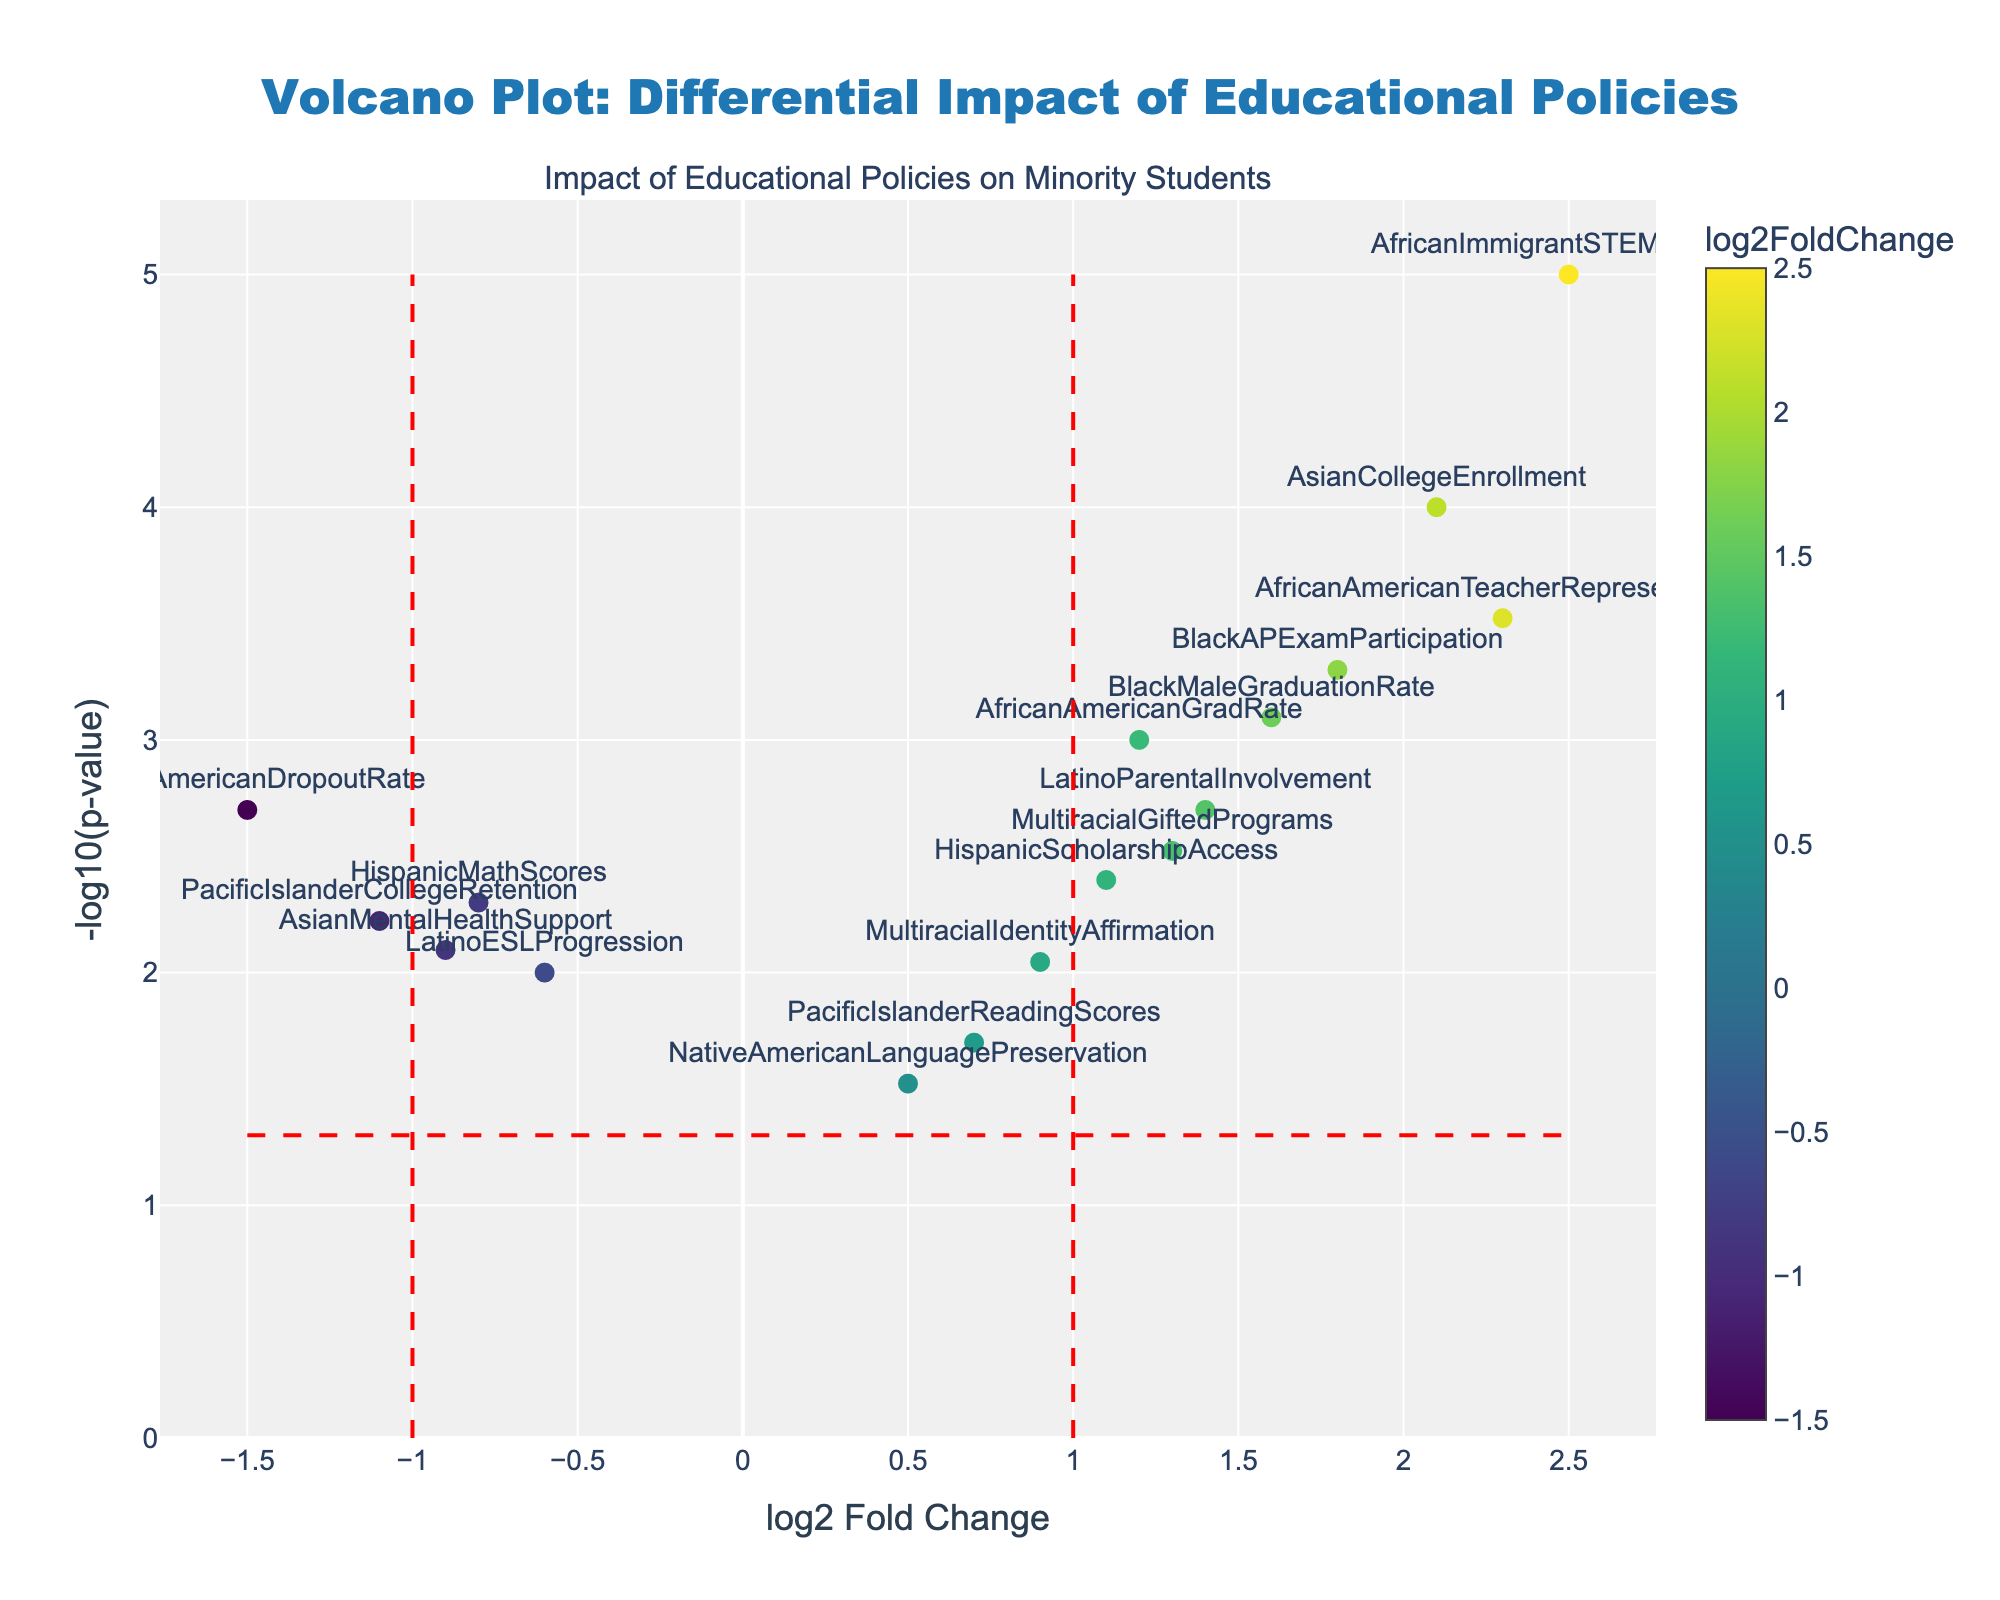What's the title of the plot? The title of the plot is displayed at the top center of the figure, inside a blue box, and reads "Volcano Plot: Differential Impact of Educational Policies".
Answer: Volcano Plot: Differential Impact of Educational Policies What does the color of the markers represent? The colors of the markers represent the "log2FoldChange" values. These colors are shown on the color scale bar on the right side of the plot.
Answer: log2FoldChange values How many data points have a -log10(p-value) greater than 3? We need to count the data points that appear above the y-axis value of 3. These are AfricanImmigrantSTEMSuccess, AsianCollegeEnrollment, BlackAPExamParticipation, AfricanAmericanTeacherRepresentation, and AfricanAmericanGradRate.
Answer: 5 Which data point has the highest log2FoldChange value? The highest log2FoldChange value can be found by looking at the farthest right data point. This is AfricanImmigrantSTEMSuccess.
Answer: AfricanImmigrantSTEMSuccess What is the log2FoldChange value of HispanicMathScores? To find the log2FoldChange for HispanicMathScores, locate this label on the plot, which is slightly to the left. The corresponding x-axis value is -0.8.
Answer: -0.8 Which data points have a positive log2FoldChange value and a p-value less than 0.01? (name them) We first consider data points with a log2FoldChange greater than 0 and a -log10(p-value) greater than 2 (since -log10(0.01) = 2). These points are AfricanAmericanGradRate, AsianCollegeEnrollment, BlackAPExamParticipation, MultiracialGiftedPrograms, AfricanImmigrantSTEMSuccess, HispanicScholarshipAccess, BlackMaleGraduationRate, LatinoParentalInvolvement, and AfricanAmericanTeacherRepresentation.
Answer: AfricanAmericanGradRate, AsianCollegeEnrollment, BlackAPExamParticipation, MultiracialGiftedPrograms, AfricanImmigrantSTEMSuccess, HispanicScholarshipAccess, BlackMaleGraduationRate, LatinoParentalInvolvement, AfricanAmericanTeacherRepresentation Which group has the lowest -log10(p-value)? The lowest -log10(p-value) is found by locating the point closest to the x-axis. This corresponds to NativeAmericanLanguagePreservation with a -log10(p-value) of approximately 1.5.
Answer: NativeAmericanLanguagePreservation What is the approximate p-value of PacificIslanderReadingScores? To find the p-value of PacificIslanderReadingScores, first locate its -log10(p-value). This point is around 1.7. So, p-value ≈ 10^(-1.7).
Answer: ~0.02 Which data point is closest to the origin? The point closest to the origin (0, 0) is PacificIslanderReadingScores, positioned near (0.7, ~1.7).
Answer: PacificIslanderReadingScores How many data points fall within the -log10(p-value) less than 2 and log2FoldChange between -1 and 1? These are points with a y-axis value less than 2 and an x-axis value between -1 and 1. The points are NativeAmericanLanguagePreservation, HispanicMathScores, PacificIslanderCollegeRetention, AsianMentalHealthSupport, NativeAmericanDropoutRate, LatinoESLProgression, MultiracialIdentityAffirmation, and PacificIslanderReadingScores.
Answer: 8 